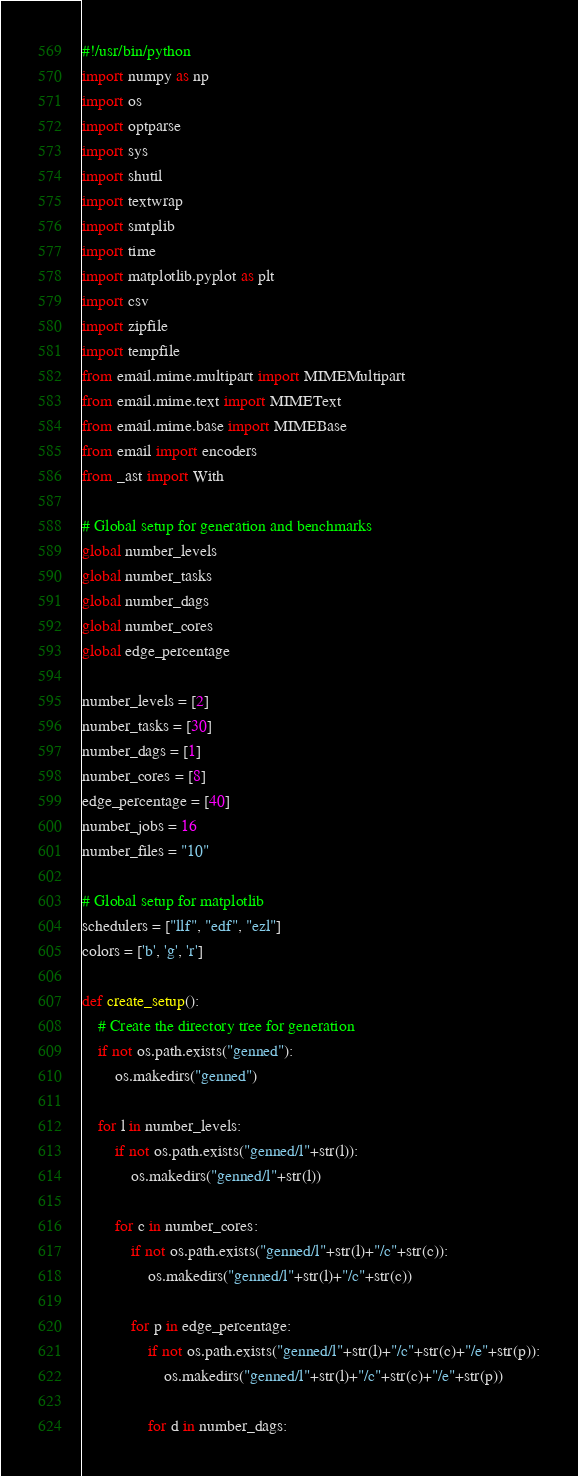Convert code to text. <code><loc_0><loc_0><loc_500><loc_500><_Python_>#!/usr/bin/python
import numpy as np
import os
import optparse
import sys
import shutil
import textwrap
import smtplib
import time
import matplotlib.pyplot as plt
import csv
import zipfile
import tempfile
from email.mime.multipart import MIMEMultipart
from email.mime.text import MIMEText
from email.mime.base import MIMEBase
from email import encoders
from _ast import With

# Global setup for generation and benchmarks
global number_levels
global number_tasks
global number_dags
global number_cores
global edge_percentage

number_levels = [2]
number_tasks = [30]
number_dags = [1]
number_cores = [8]
edge_percentage = [40]
number_jobs = 16
number_files = "10"

# Global setup for matplotlib
schedulers = ["llf", "edf", "ezl"]
colors = ['b', 'g', 'r']

def create_setup():
    # Create the directory tree for generation
    if not os.path.exists("genned"):
        os.makedirs("genned")
        
    for l in number_levels:
        if not os.path.exists("genned/l"+str(l)):
            os.makedirs("genned/l"+str(l))

        for c in number_cores:
            if not os.path.exists("genned/l"+str(l)+"/c"+str(c)):
                os.makedirs("genned/l"+str(l)+"/c"+str(c))

            for p in edge_percentage:
                if not os.path.exists("genned/l"+str(l)+"/c"+str(c)+"/e"+str(p)):
                    os.makedirs("genned/l"+str(l)+"/c"+str(c)+"/e"+str(p))

                for d in number_dags:</code> 